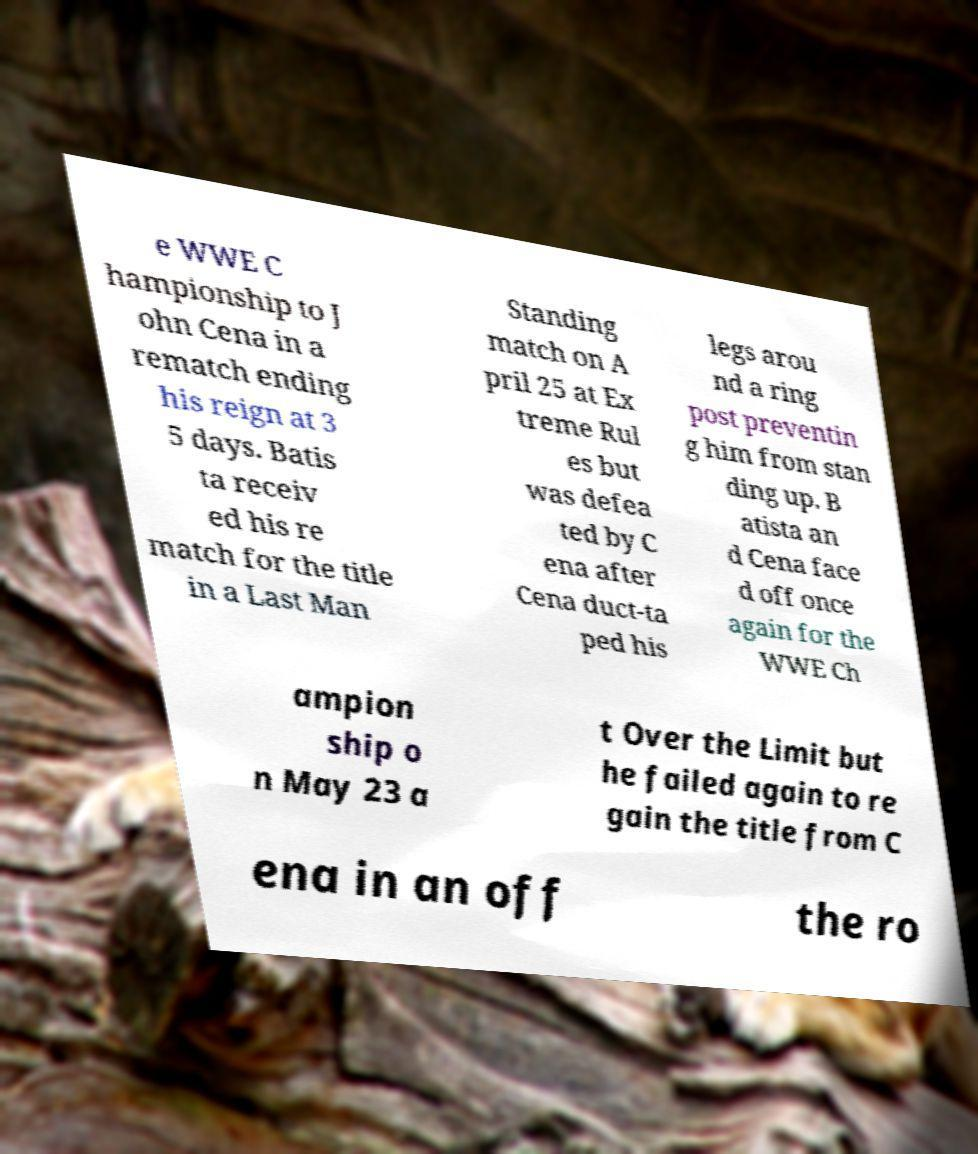Can you read and provide the text displayed in the image?This photo seems to have some interesting text. Can you extract and type it out for me? e WWE C hampionship to J ohn Cena in a rematch ending his reign at 3 5 days. Batis ta receiv ed his re match for the title in a Last Man Standing match on A pril 25 at Ex treme Rul es but was defea ted by C ena after Cena duct-ta ped his legs arou nd a ring post preventin g him from stan ding up. B atista an d Cena face d off once again for the WWE Ch ampion ship o n May 23 a t Over the Limit but he failed again to re gain the title from C ena in an off the ro 